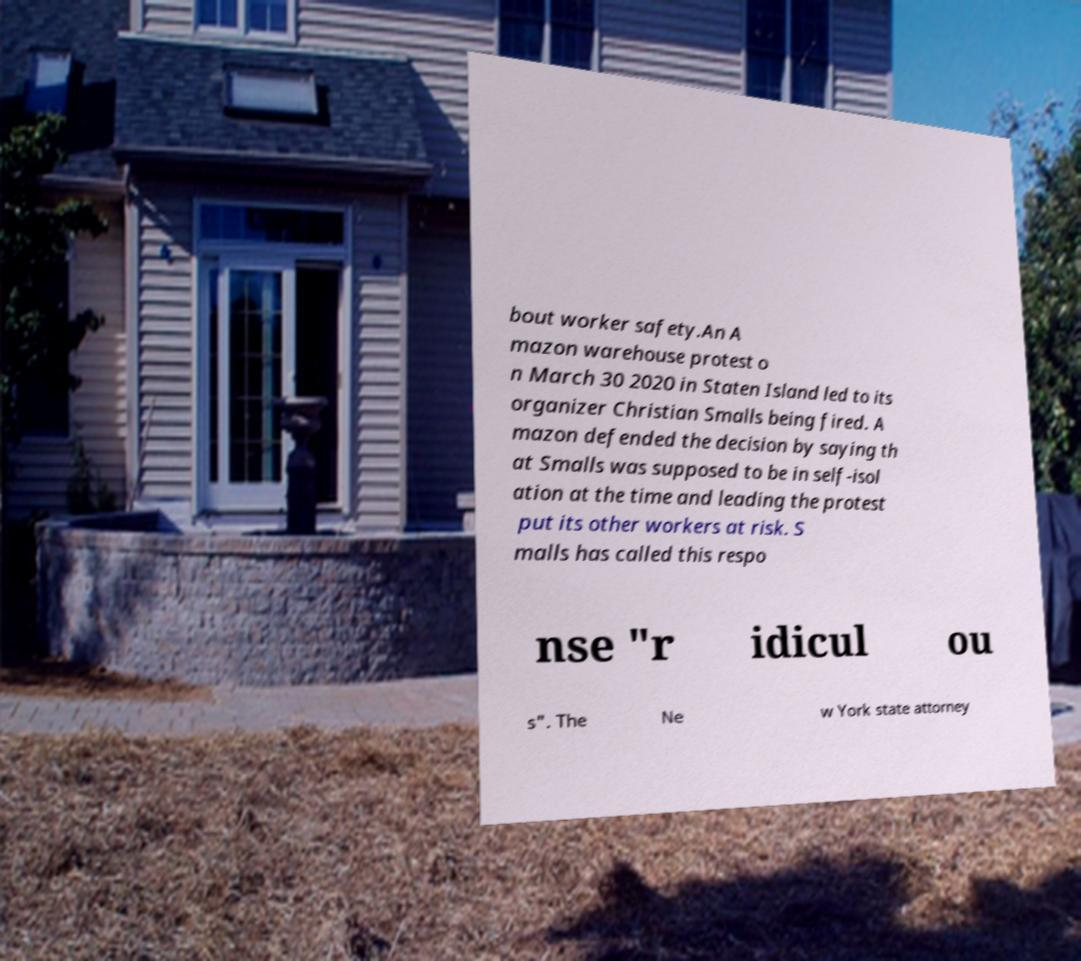Can you read and provide the text displayed in the image?This photo seems to have some interesting text. Can you extract and type it out for me? bout worker safety.An A mazon warehouse protest o n March 30 2020 in Staten Island led to its organizer Christian Smalls being fired. A mazon defended the decision by saying th at Smalls was supposed to be in self-isol ation at the time and leading the protest put its other workers at risk. S malls has called this respo nse "r idicul ou s". The Ne w York state attorney 